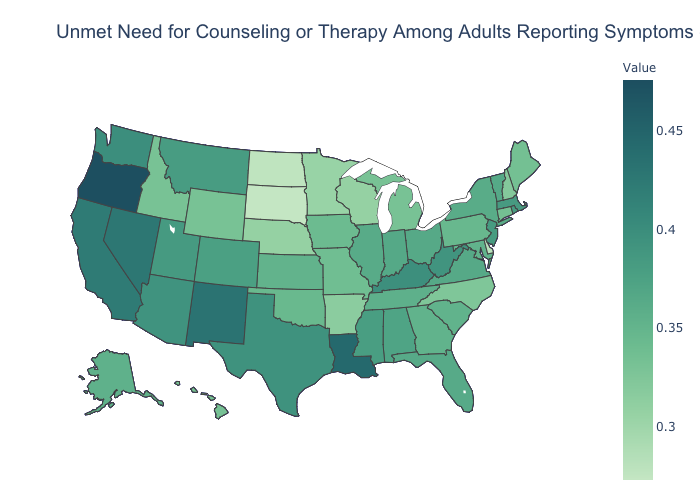Which states have the lowest value in the USA?
Be succinct. South Dakota. Does the map have missing data?
Write a very short answer. No. Which states have the lowest value in the West?
Concise answer only. Idaho, Wyoming. Among the states that border Wyoming , which have the highest value?
Be succinct. Utah. Among the states that border Louisiana , does Texas have the highest value?
Keep it brief. Yes. Does Illinois have the lowest value in the USA?
Quick response, please. No. Among the states that border West Virginia , does Kentucky have the highest value?
Give a very brief answer. Yes. 